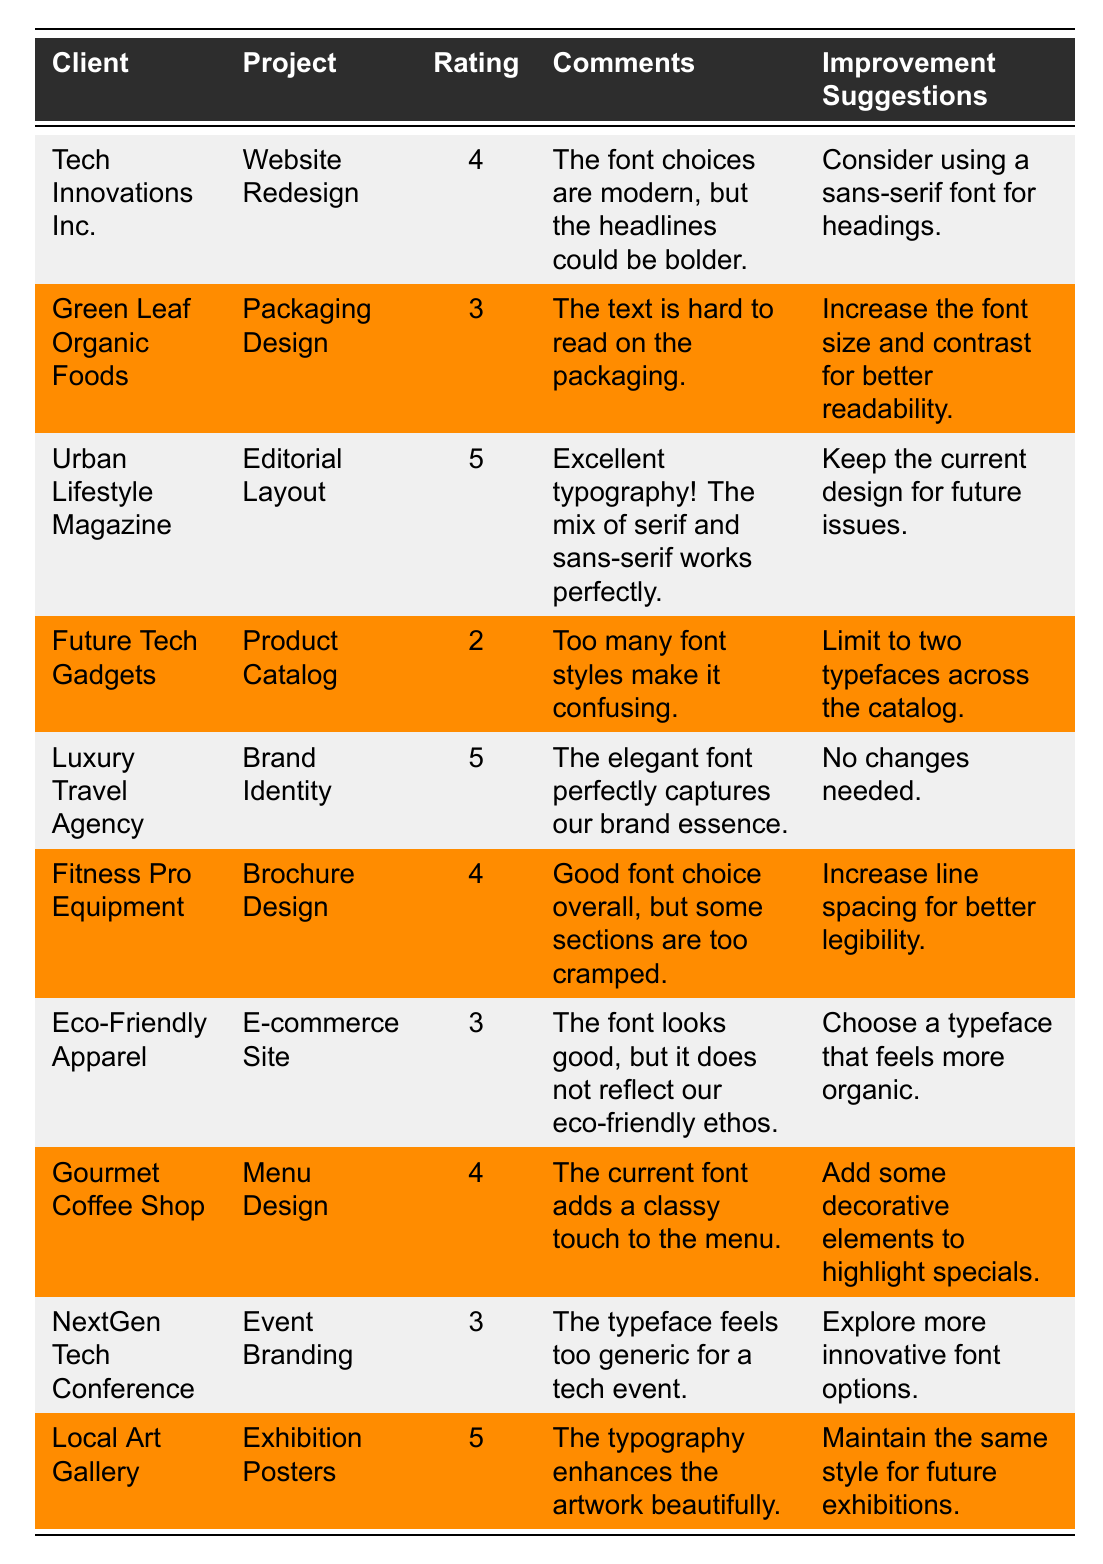What is the highest rating given in the feedback? The ratings are 4, 3, 5, 2, 5, 4, 3, 4, 3, and 5. The highest value among these is 5.
Answer: 5 Which project received a rating of 2? Looking at the table, the project "Product Catalog" from the client "Future Tech Gadgets" received a rating of 2.
Answer: Product Catalog What improvement suggestion was made for "Eco-Friendly Apparel"? The table shows that the improvement suggestion for "Eco-Friendly Apparel" is to "Choose a typeface that feels more organic."
Answer: Choose a typeface that feels more organic How many projects received a rating of 4? The projects with a rating of 4 are "Website Redesign," "Brochure Design," and "Menu Design," totaling three.
Answer: 3 What was the client's feedback for the "Website Redesign"? The comments from the client "Tech Innovations Inc." state that "The font choices are modern, but the headlines could be bolder."
Answer: The font choices are modern, but the headlines could be bolder Did any project receive the same rating as "Packaging Design"? "Packaging Design" received a rating of 3. The projects "E-commerce Site" and "Event Branding" also have a rating of 3, thus confirming that there are projects with the same rating.
Answer: Yes What is the average rating of all the projects? The sum of ratings (4 + 3 + 5 + 2 + 5 + 4 + 3 + 4 + 3 + 5) is 43, and there are 10 projects. The average is 43 divided by 10, which equals 4.3.
Answer: 4.3 Which client mentioned that their current font adds a classy touch? The client "Gourmet Coffee Shop" provided this feedback in the comments about the "Menu Design" project.
Answer: Gourmet Coffee Shop What were the improvement suggestions for projects that received a rating of 4? The projects rated 4 are "Website Redesign" with "Consider using a sans-serif font for headings," "Brochure Design" with "Increase line spacing for better legibility," and "Menu Design" suggesting "Add some decorative elements to highlight specials."
Answer: Three improvement suggestions What rating did the "Local Art Gallery" receive for its project? The client "Local Art Gallery" rated their project, "Exhibition Posters," with a score of 5.
Answer: 5 